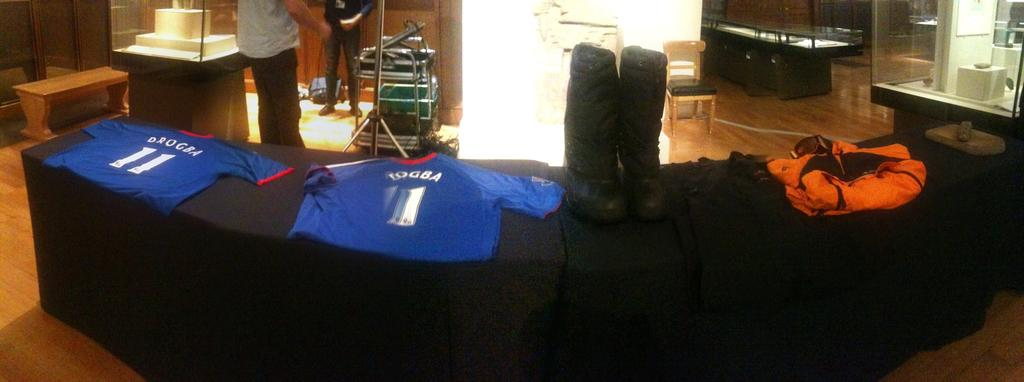<image>
Create a compact narrative representing the image presented. Table with soccer jerseys on display showing the names and number on them. 